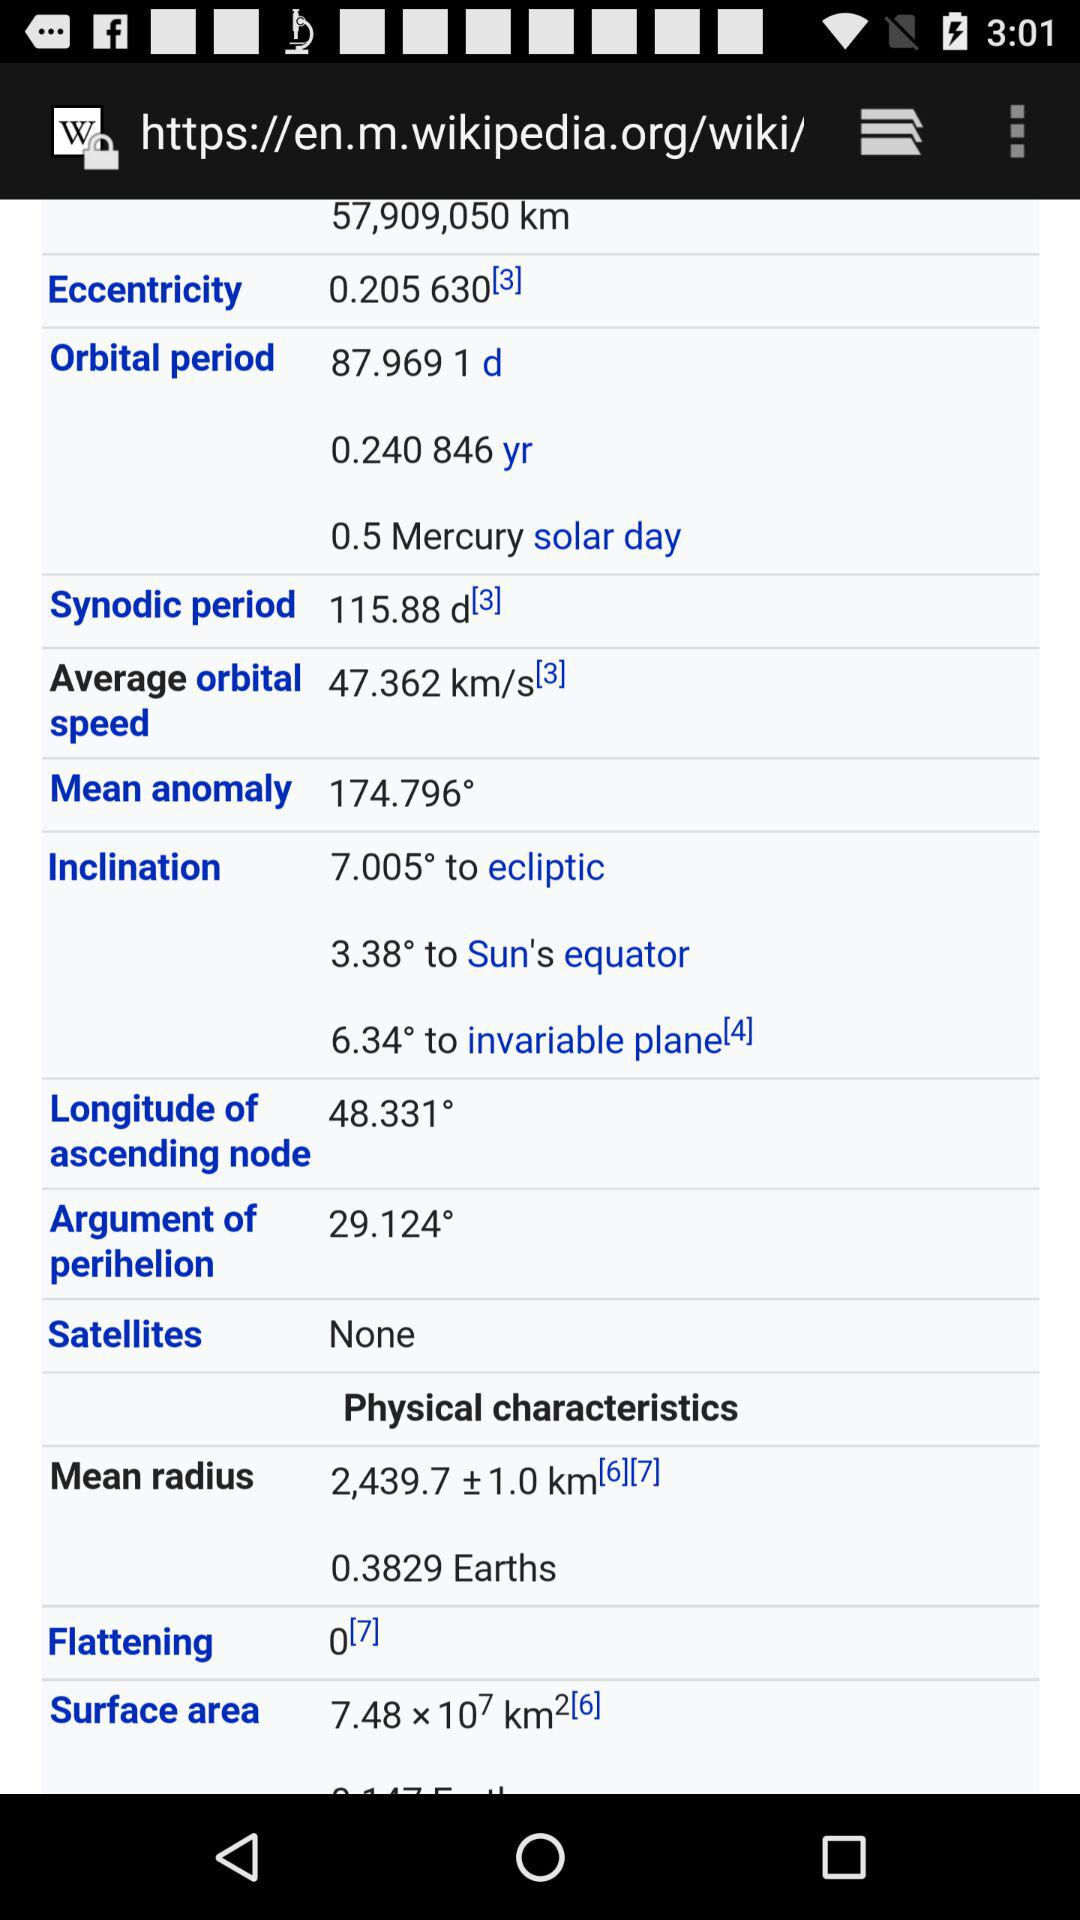How many satellites does Mercury have?
Answer the question using a single word or phrase. None 